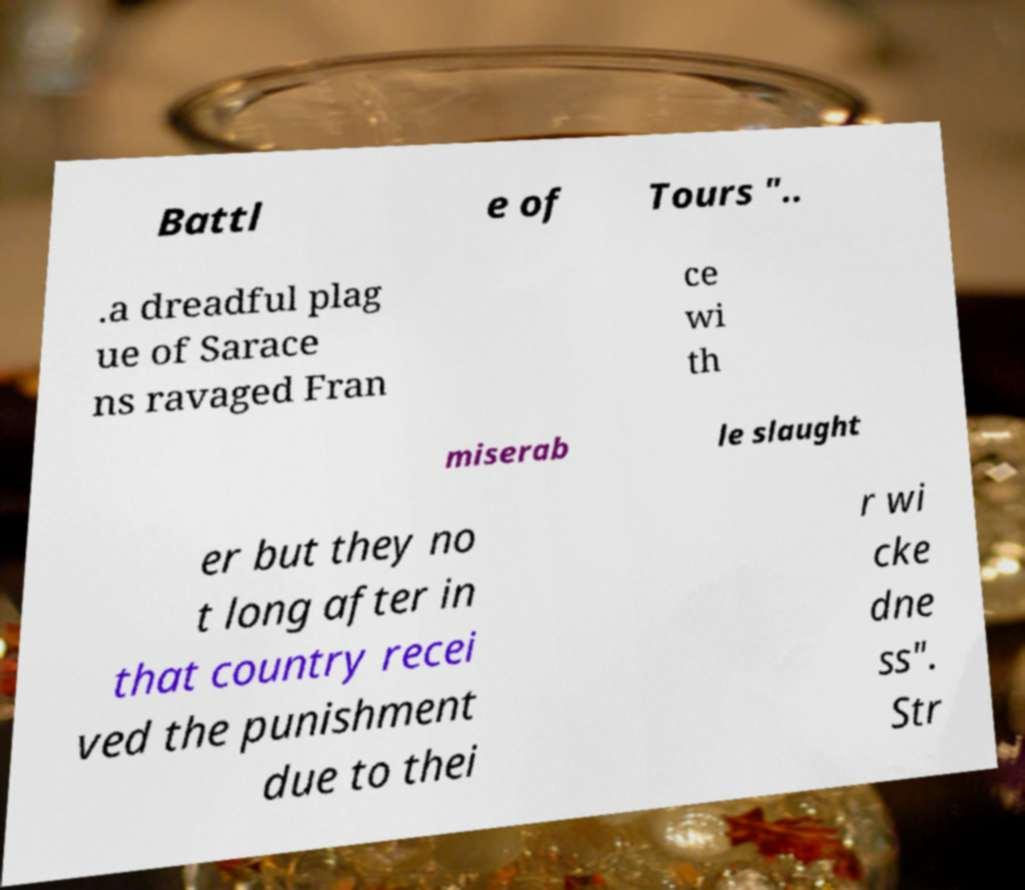I need the written content from this picture converted into text. Can you do that? Battl e of Tours ".. .a dreadful plag ue of Sarace ns ravaged Fran ce wi th miserab le slaught er but they no t long after in that country recei ved the punishment due to thei r wi cke dne ss". Str 